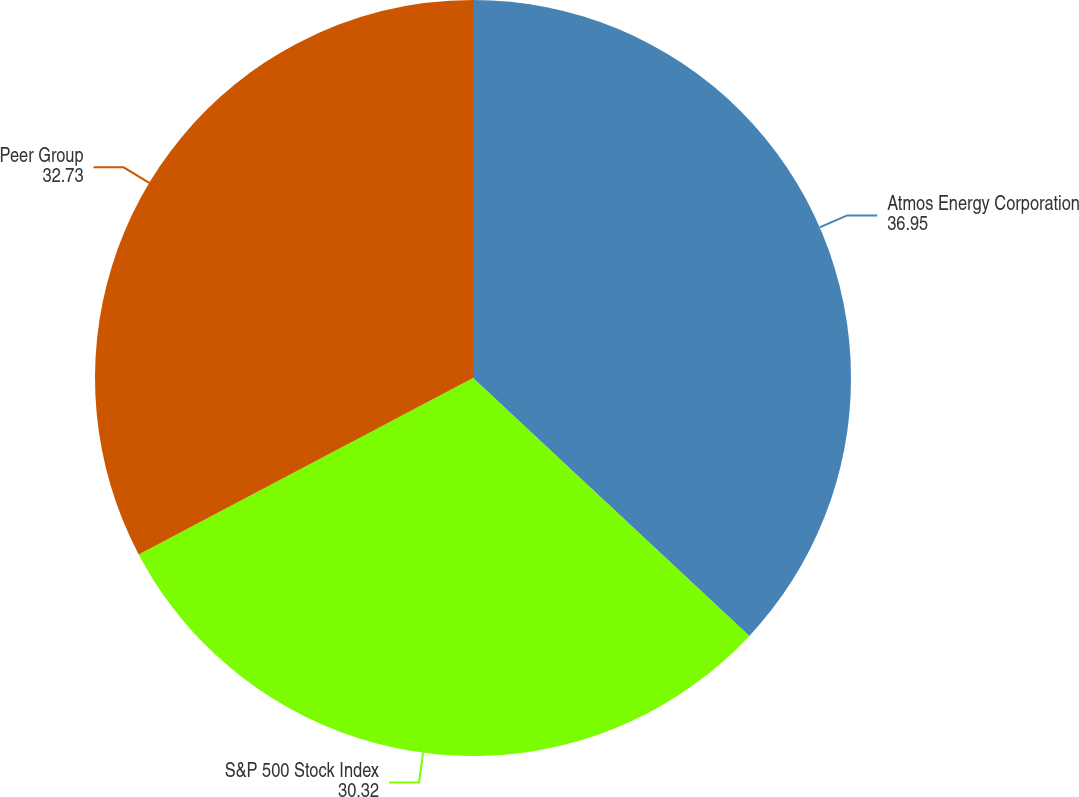<chart> <loc_0><loc_0><loc_500><loc_500><pie_chart><fcel>Atmos Energy Corporation<fcel>S&P 500 Stock Index<fcel>Peer Group<nl><fcel>36.95%<fcel>30.32%<fcel>32.73%<nl></chart> 